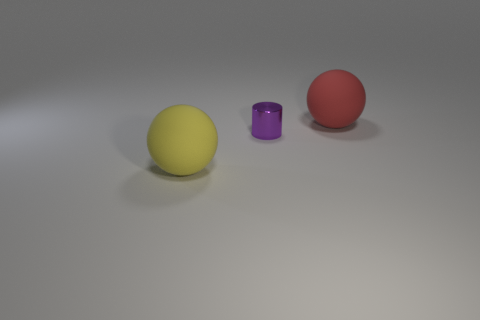What possible uses might these objects have in a real-world setting? In a real-world context, the spheres could be decorative objects or perhaps part of a children's playset due to their bright colors and matte finish. The small metallic cylinder might serve as a container or a decorative piece with functional potential, possibly as a stationary holder or miniature vase. 